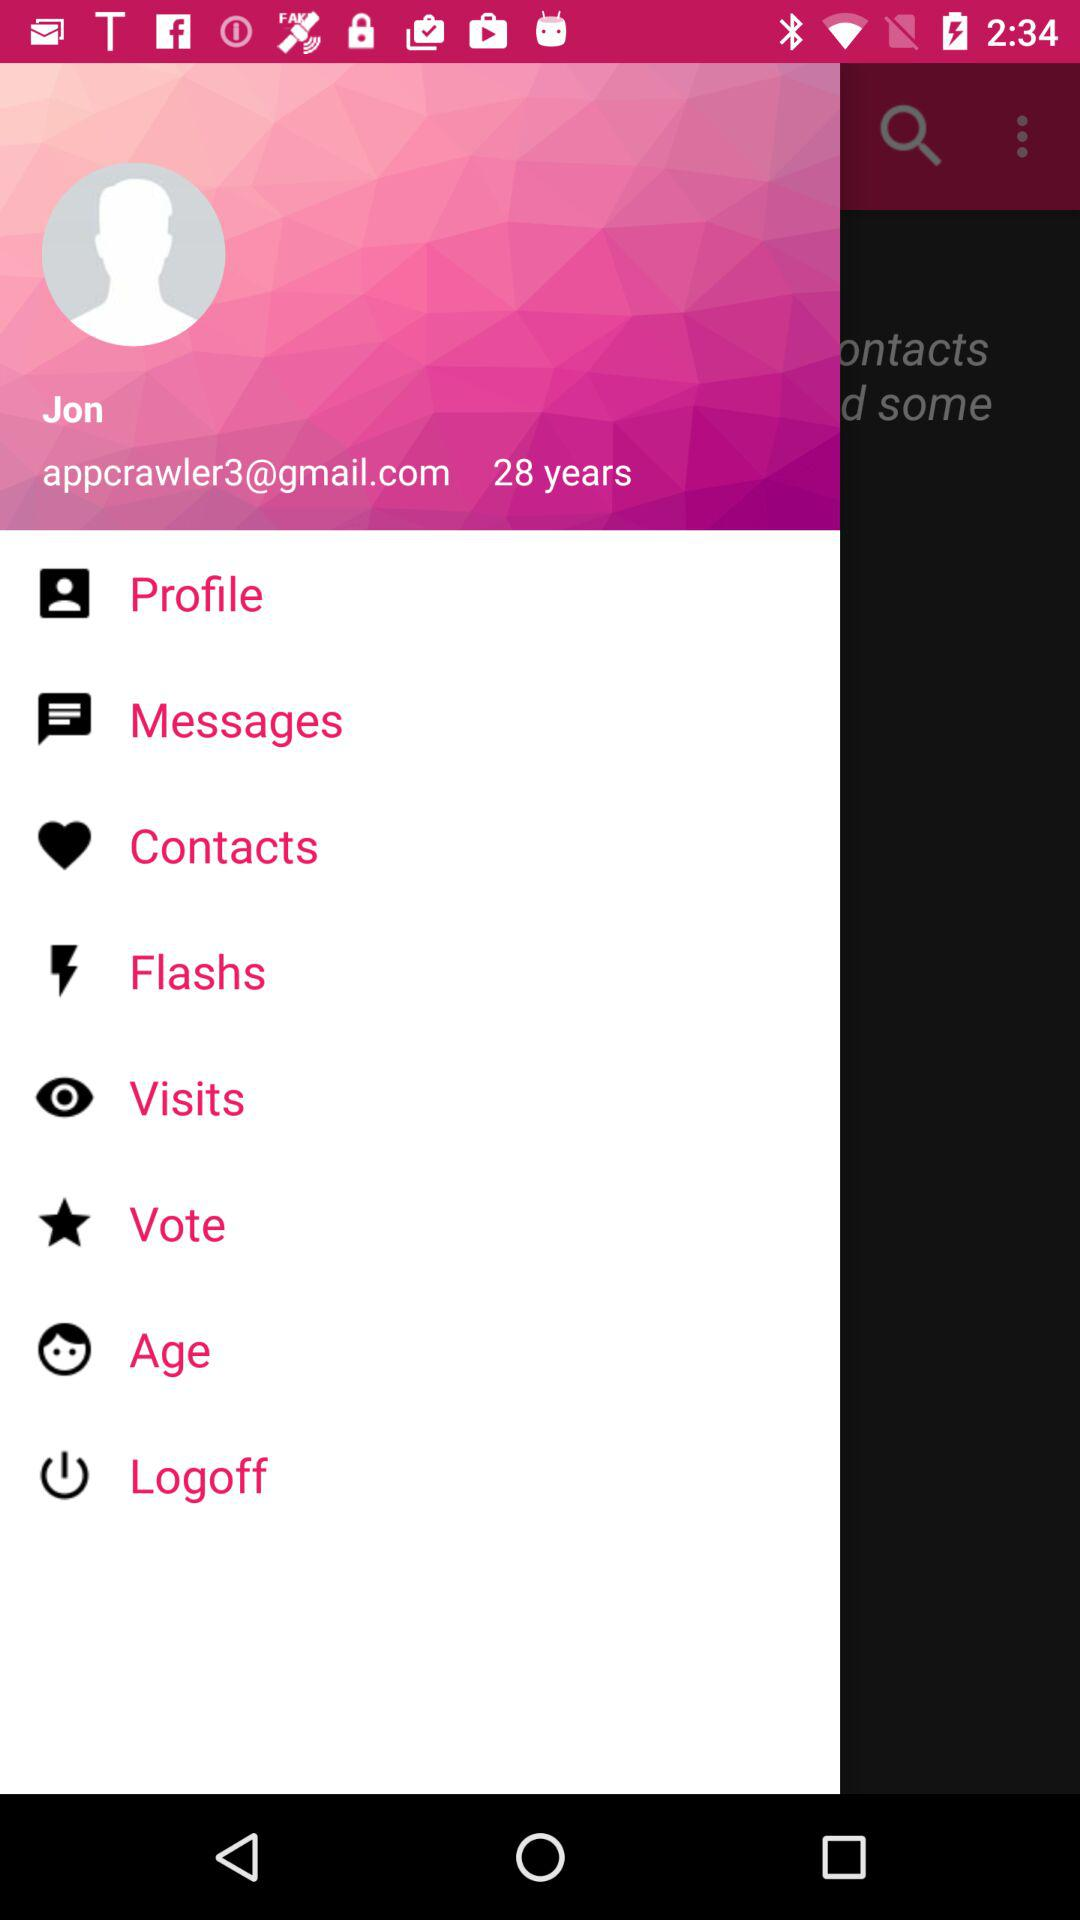What is the email address? The email address is appcrawler3@gmail.com. 